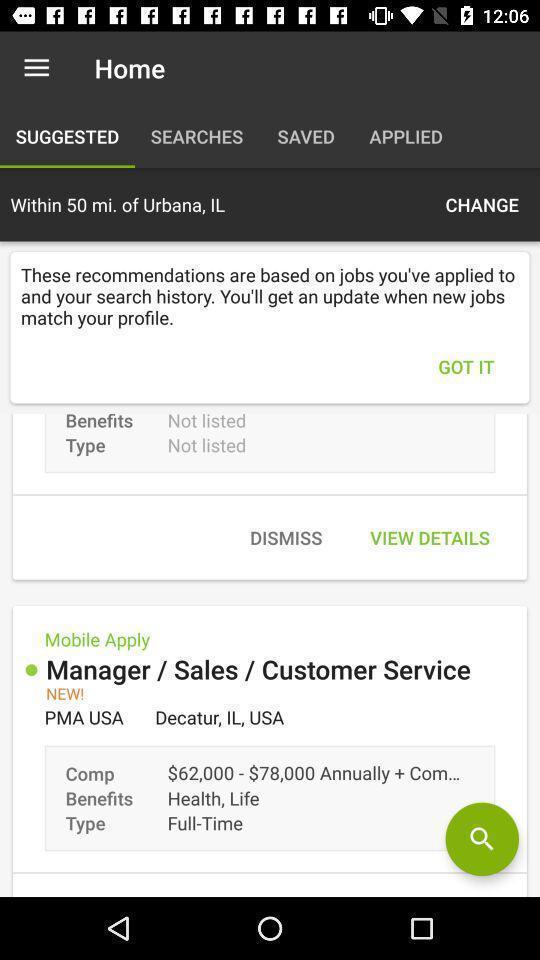Explain the elements present in this screenshot. Suggested page of the home. 